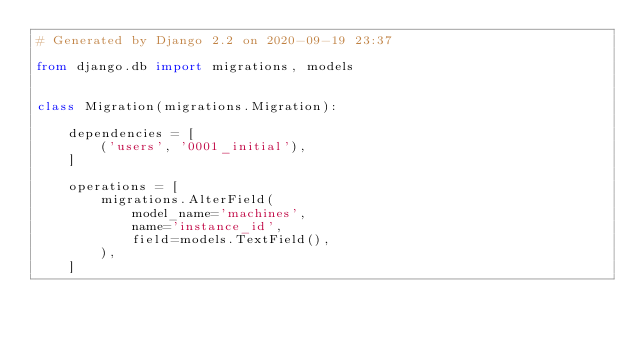Convert code to text. <code><loc_0><loc_0><loc_500><loc_500><_Python_># Generated by Django 2.2 on 2020-09-19 23:37

from django.db import migrations, models


class Migration(migrations.Migration):

    dependencies = [
        ('users', '0001_initial'),
    ]

    operations = [
        migrations.AlterField(
            model_name='machines',
            name='instance_id',
            field=models.TextField(),
        ),
    ]
</code> 